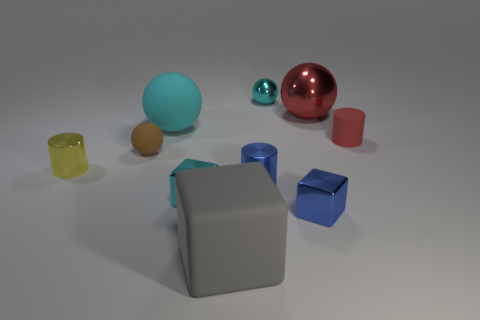Subtract all cubes. How many objects are left? 7 Add 2 small cubes. How many small cubes are left? 4 Add 9 small yellow metal cubes. How many small yellow metal cubes exist? 9 Subtract 1 yellow cylinders. How many objects are left? 9 Subtract all small blue shiny things. Subtract all red shiny things. How many objects are left? 7 